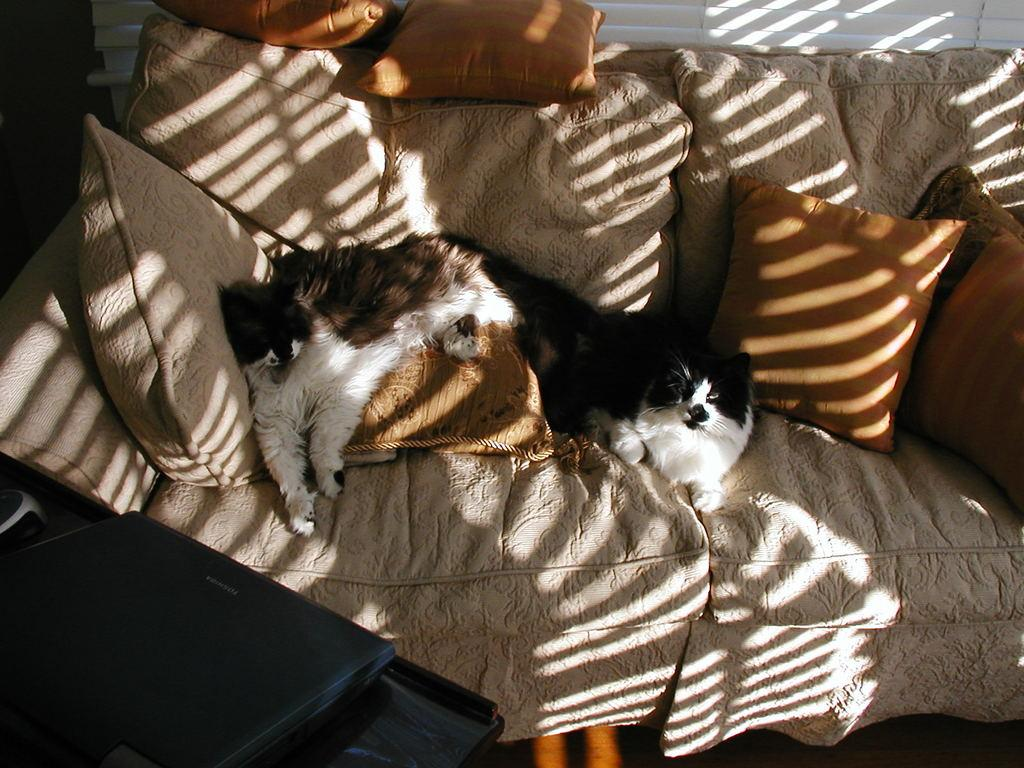How many cats are in the image? There are 2 cats in the image. Where are the cats located in the image? The cats are on a couch in the image. What else can be seen on the couch besides the cats? There are cushions visible on the couch in the image. What electronic device is visible in the image? There is a laptop visible in the image. What type of science is being taught in the image? There is no indication of any teaching or science-related activity in the image. 